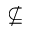<formula> <loc_0><loc_0><loc_500><loc_500>\nsubseteq</formula> 